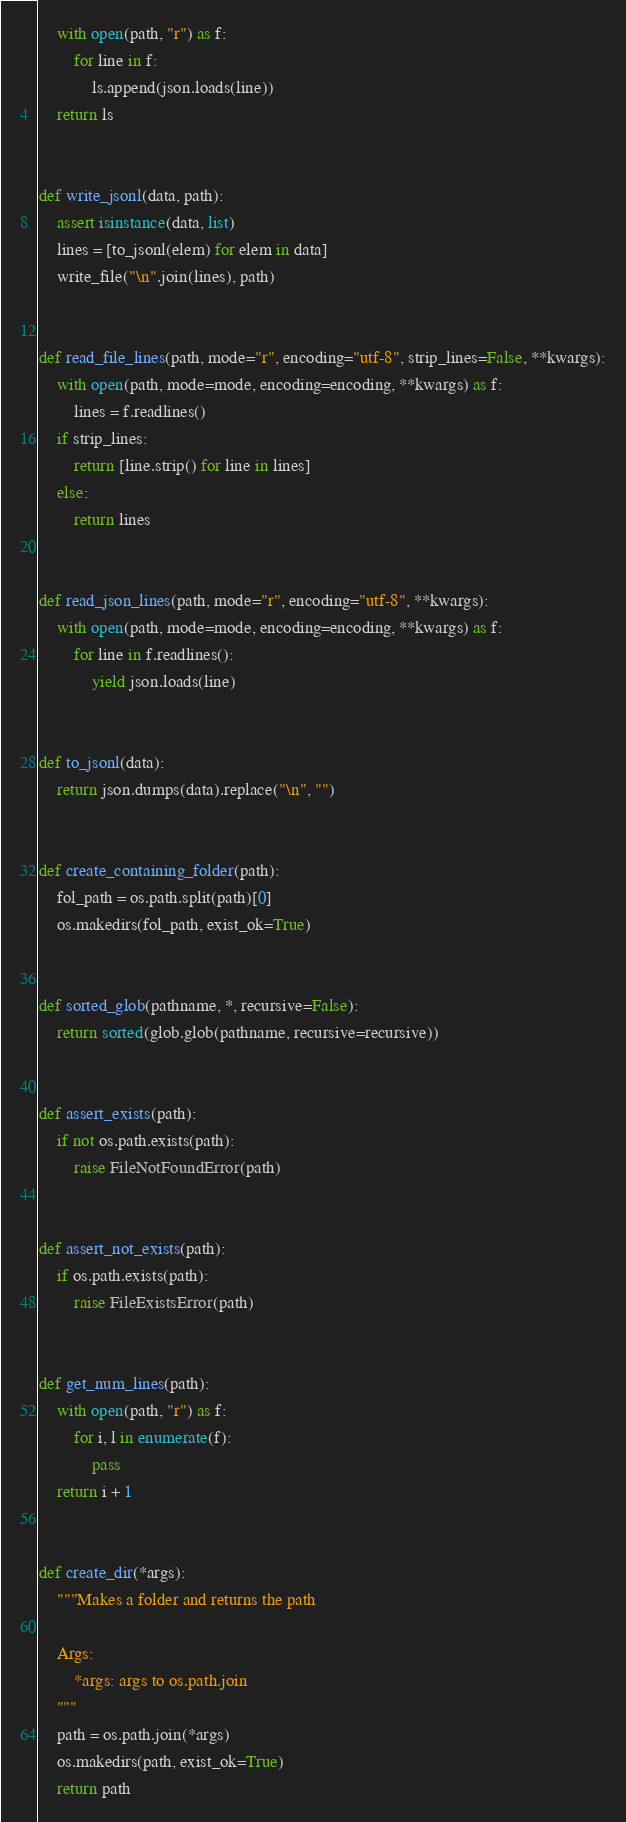Convert code to text. <code><loc_0><loc_0><loc_500><loc_500><_Python_>    with open(path, "r") as f:
        for line in f:
            ls.append(json.loads(line))
    return ls


def write_jsonl(data, path):
    assert isinstance(data, list)
    lines = [to_jsonl(elem) for elem in data]
    write_file("\n".join(lines), path)


def read_file_lines(path, mode="r", encoding="utf-8", strip_lines=False, **kwargs):
    with open(path, mode=mode, encoding=encoding, **kwargs) as f:
        lines = f.readlines()
    if strip_lines:
        return [line.strip() for line in lines]
    else:
        return lines


def read_json_lines(path, mode="r", encoding="utf-8", **kwargs):
    with open(path, mode=mode, encoding=encoding, **kwargs) as f:
        for line in f.readlines():
            yield json.loads(line)


def to_jsonl(data):
    return json.dumps(data).replace("\n", "")


def create_containing_folder(path):
    fol_path = os.path.split(path)[0]
    os.makedirs(fol_path, exist_ok=True)


def sorted_glob(pathname, *, recursive=False):
    return sorted(glob.glob(pathname, recursive=recursive))


def assert_exists(path):
    if not os.path.exists(path):
        raise FileNotFoundError(path)


def assert_not_exists(path):
    if os.path.exists(path):
        raise FileExistsError(path)


def get_num_lines(path):
    with open(path, "r") as f:
        for i, l in enumerate(f):
            pass
    return i + 1


def create_dir(*args):
    """Makes a folder and returns the path

    Args:
        *args: args to os.path.join
    """
    path = os.path.join(*args)
    os.makedirs(path, exist_ok=True)
    return path
</code> 